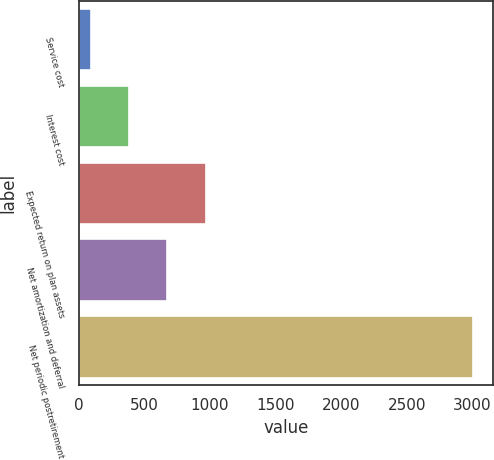<chart> <loc_0><loc_0><loc_500><loc_500><bar_chart><fcel>Service cost<fcel>Interest cost<fcel>Expected return on plan assets<fcel>Net amortization and deferral<fcel>Net periodic postretirement<nl><fcel>93<fcel>384.4<fcel>967.2<fcel>675.8<fcel>3007<nl></chart> 